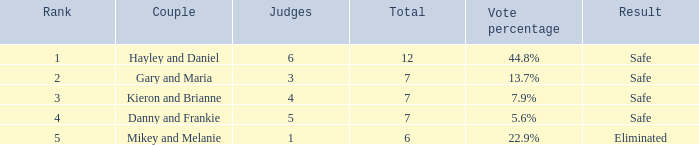What was the result for the total of 12? Safe. 